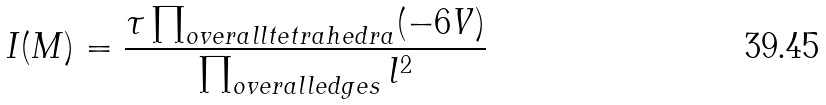<formula> <loc_0><loc_0><loc_500><loc_500>I ( M ) = \frac { \tau \prod _ { o v e r a l l t e t r a h e d r a } ( - 6 V ) } { \prod _ { o v e r a l l e d g e s } l ^ { 2 } }</formula> 